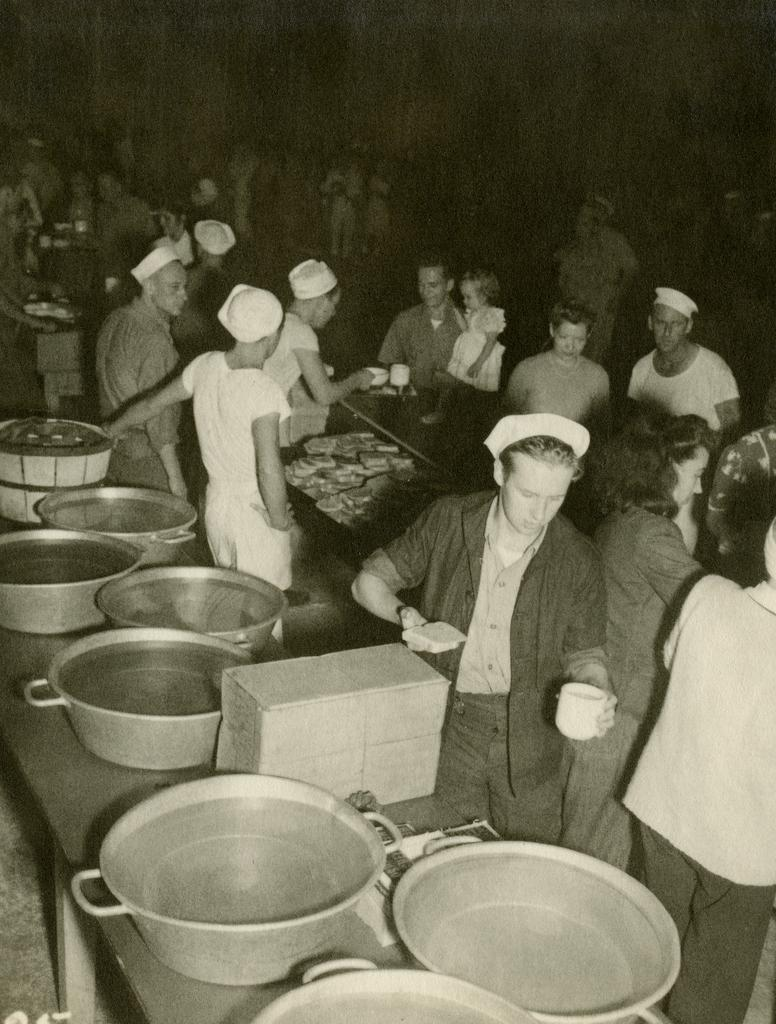What is happening in the image involving the people? Some of the people are serving food in the image. What type of containers can be seen in the image? There are bowls in the image. What type of food is visible in the image? There is bread in the image. What type of beverage containers are present in the image? There are cups in the image. Can you describe the background of the image? The background of the image is blurred. Where is the nest located in the image? There is no nest present in the image. What type of roll is being used to serve the food in the image? There is no roll being used to serve the food in the image; people are using their hands or utensils. 